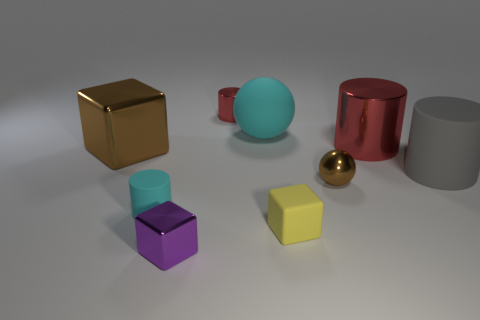What shape is the big cyan thing that is the same material as the small cyan cylinder?
Keep it short and to the point. Sphere. Is there any other thing that has the same shape as the large gray thing?
Your response must be concise. Yes. Is the material of the sphere that is on the left side of the small brown thing the same as the tiny cyan object?
Your response must be concise. Yes. What material is the tiny cylinder behind the big cyan thing?
Offer a terse response. Metal. There is a rubber cylinder that is left of the big metallic object on the right side of the tiny brown sphere; what is its size?
Your answer should be compact. Small. What number of brown matte cylinders have the same size as the purple shiny cube?
Give a very brief answer. 0. Does the tiny block that is in front of the tiny yellow object have the same color as the large shiny thing that is on the left side of the tiny sphere?
Provide a succinct answer. No. There is a gray cylinder; are there any small brown metallic spheres behind it?
Ensure brevity in your answer.  No. There is a tiny metal thing that is in front of the tiny shiny cylinder and right of the small purple metal thing; what is its color?
Your answer should be compact. Brown. Is there another metallic cylinder of the same color as the large metal cylinder?
Offer a terse response. Yes. 